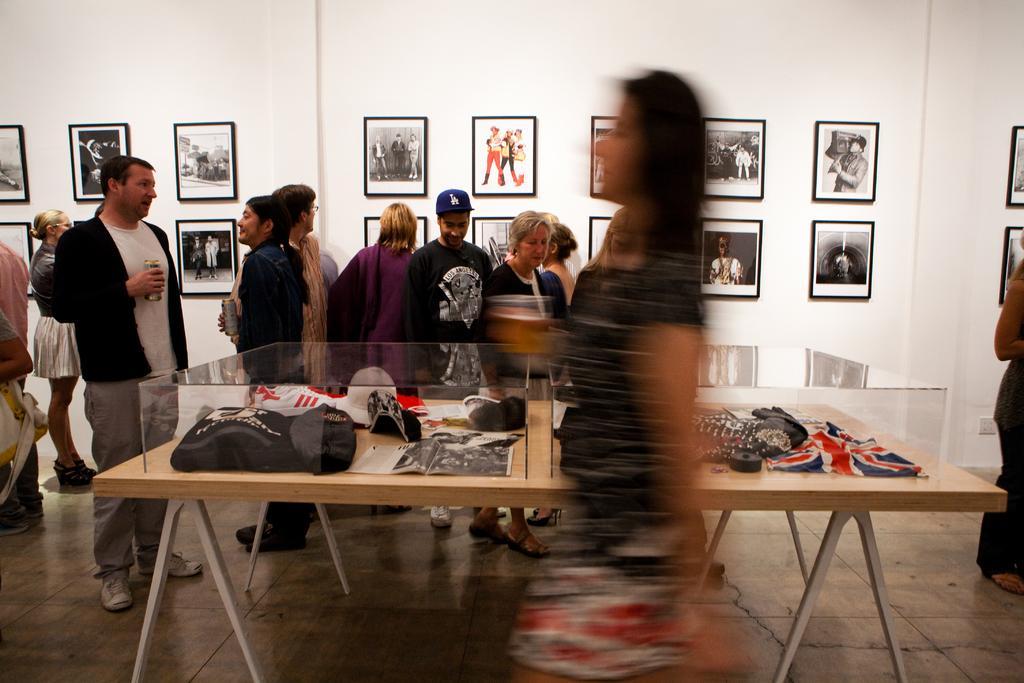How would you summarize this image in a sentence or two? In this image I can see there are the number of persons standing on the floor ,in front of them there is a table,on the table there are different clothes kept on that. On the back ground I can see a wall and there are some photo frames attached to the wall 